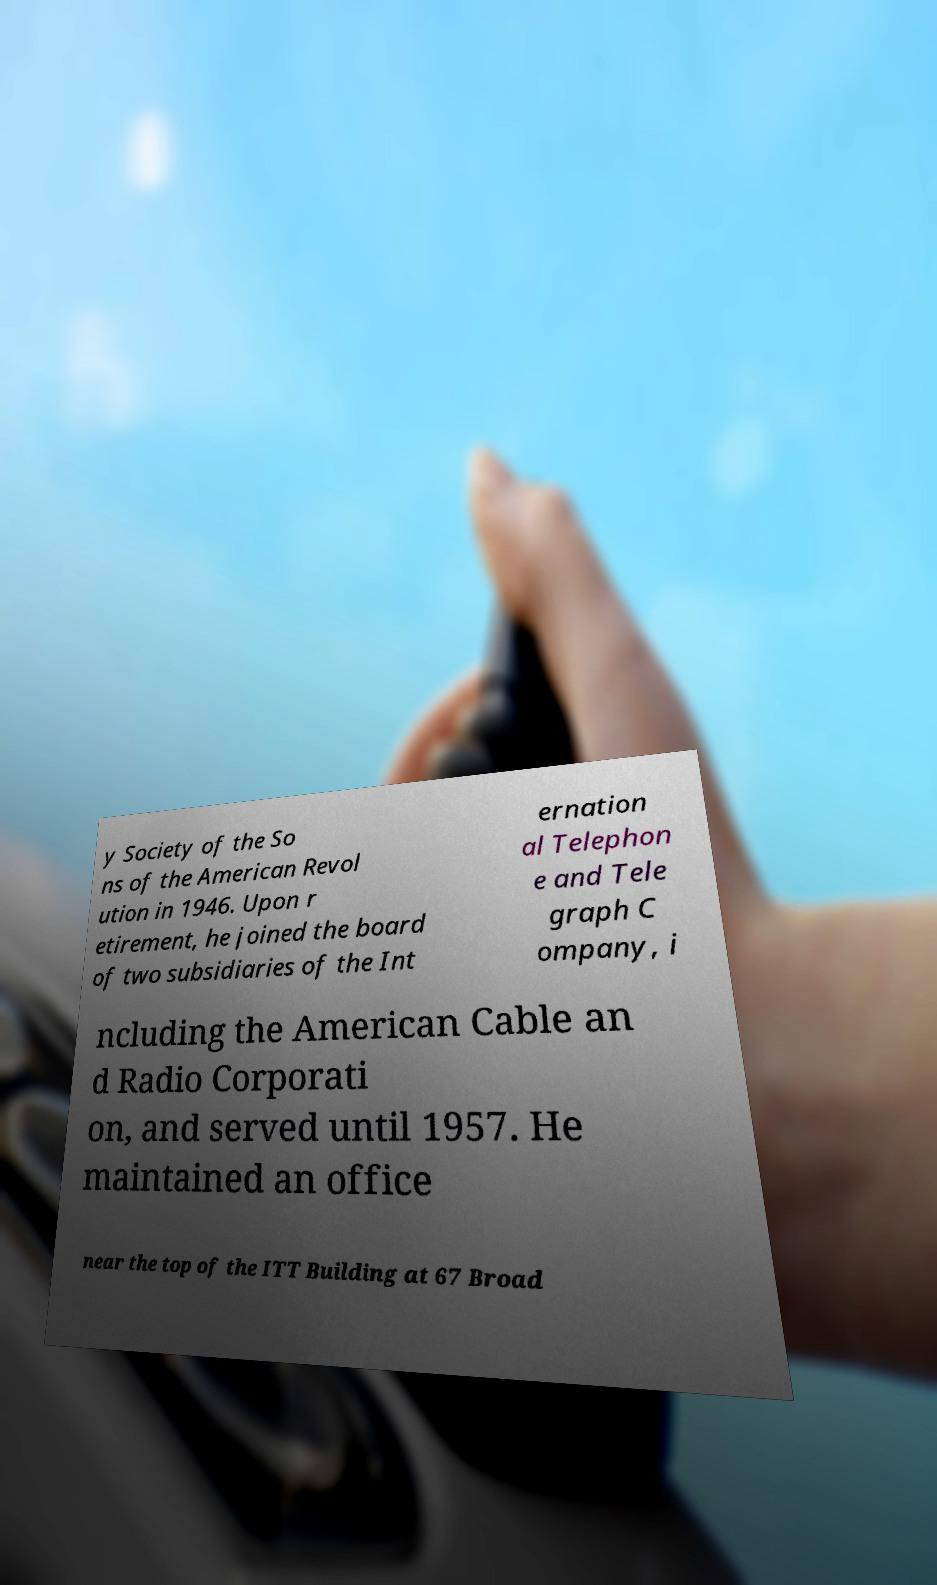Can you accurately transcribe the text from the provided image for me? y Society of the So ns of the American Revol ution in 1946. Upon r etirement, he joined the board of two subsidiaries of the Int ernation al Telephon e and Tele graph C ompany, i ncluding the American Cable an d Radio Corporati on, and served until 1957. He maintained an office near the top of the ITT Building at 67 Broad 